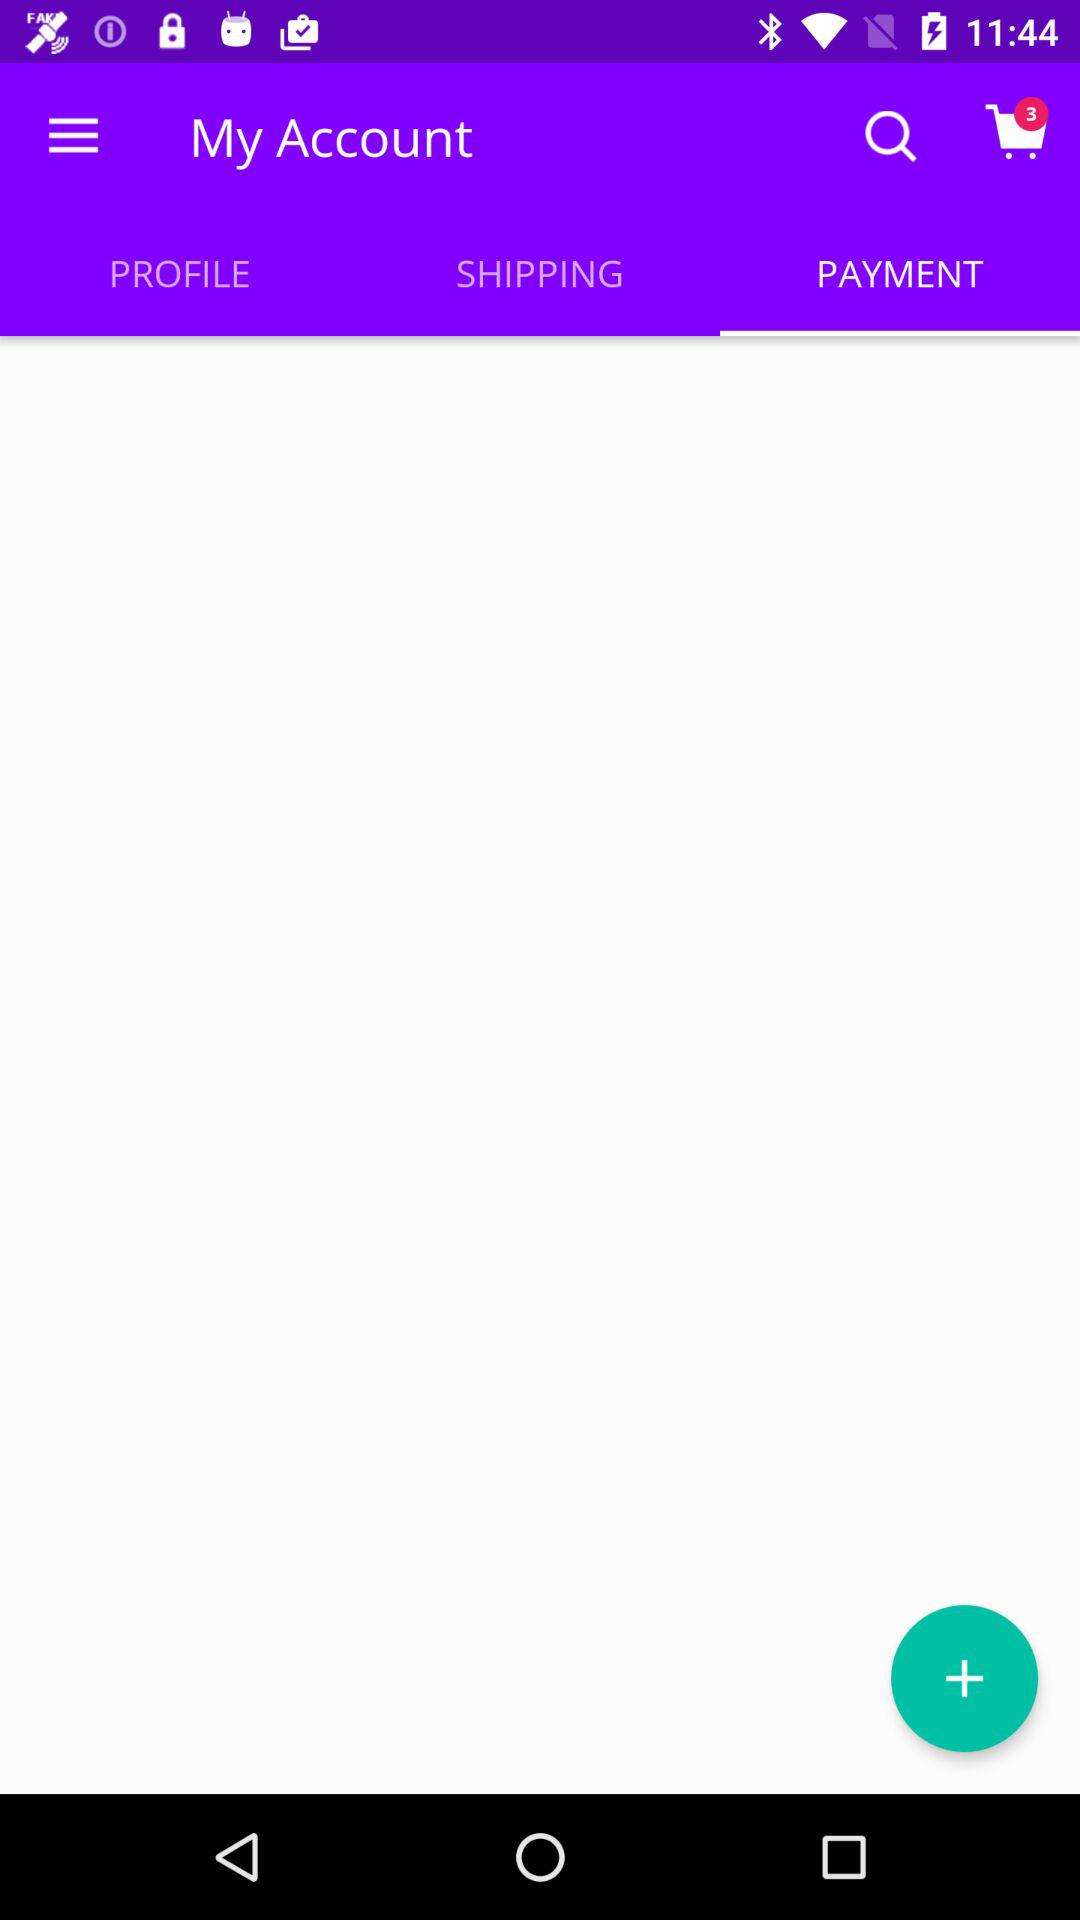How many items are there in the cart? There are 3 items in the cart. 